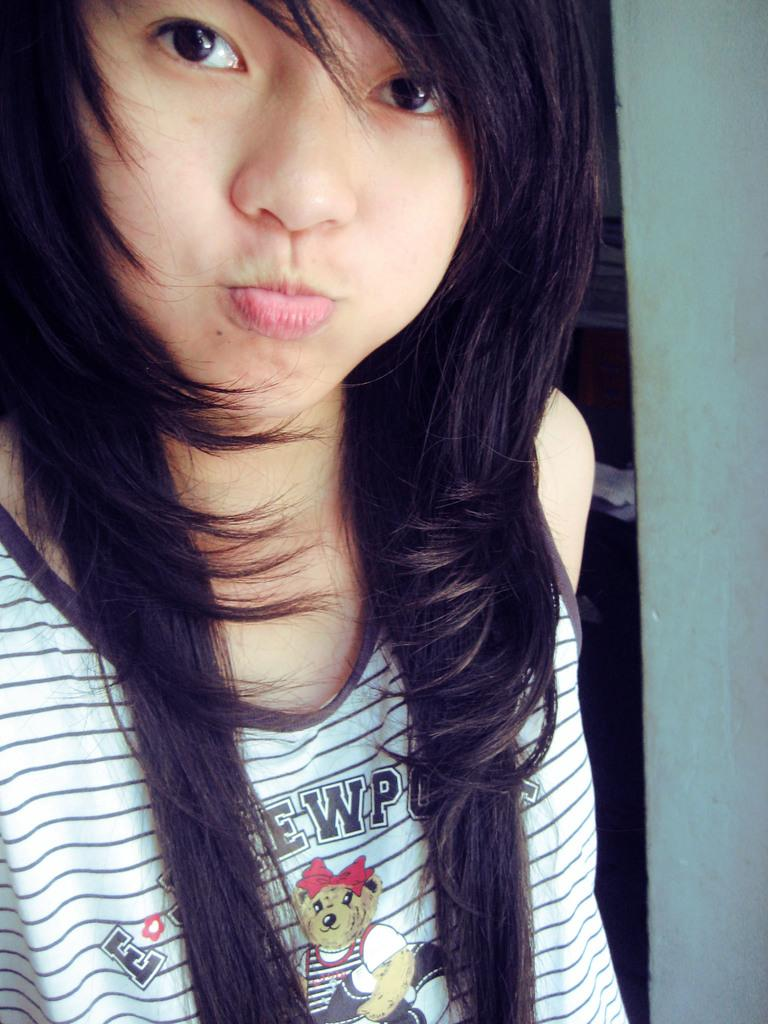Who is present in the image? There is a woman in the image. What can be seen in the background of the image? There is a wall in the background of the image. How much wealth does the woman have in the image? There is no information about the woman's wealth in the image. 